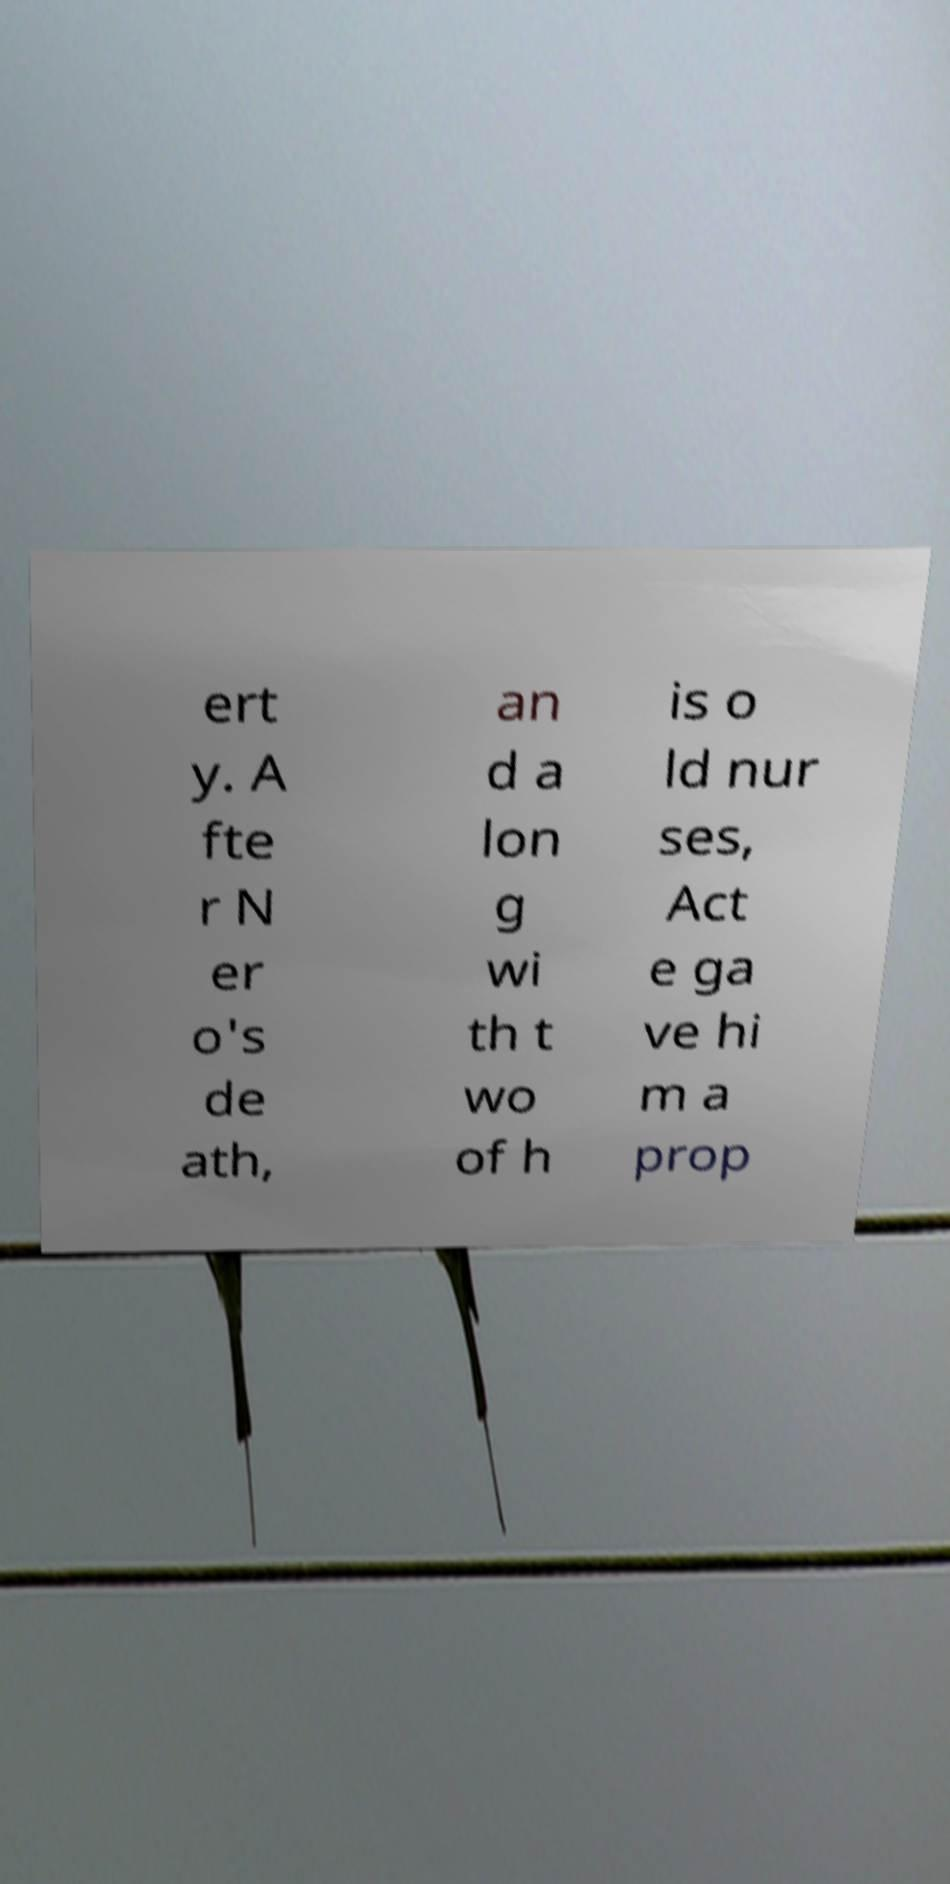I need the written content from this picture converted into text. Can you do that? ert y. A fte r N er o's de ath, an d a lon g wi th t wo of h is o ld nur ses, Act e ga ve hi m a prop 